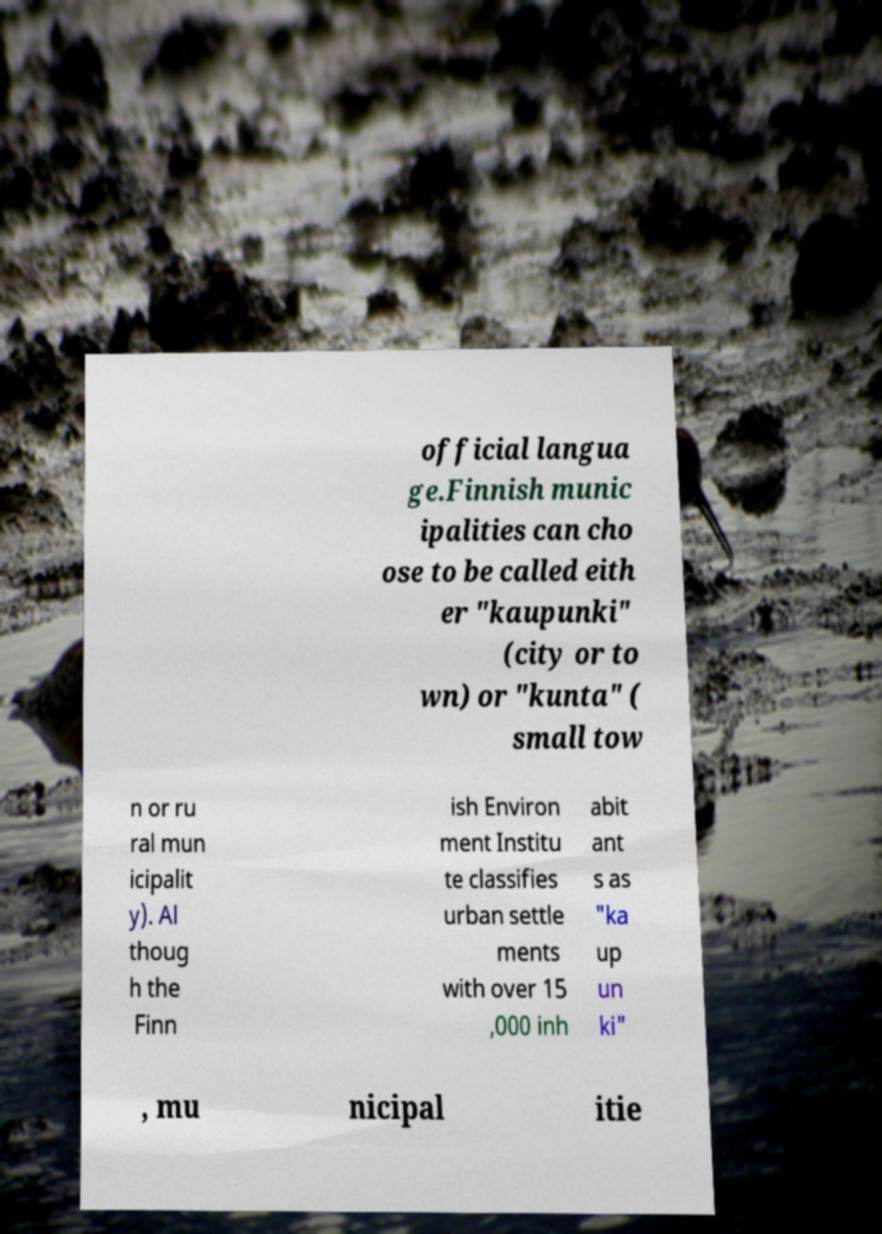Please read and relay the text visible in this image. What does it say? official langua ge.Finnish munic ipalities can cho ose to be called eith er "kaupunki" (city or to wn) or "kunta" ( small tow n or ru ral mun icipalit y). Al thoug h the Finn ish Environ ment Institu te classifies urban settle ments with over 15 ,000 inh abit ant s as "ka up un ki" , mu nicipal itie 